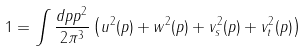<formula> <loc_0><loc_0><loc_500><loc_500>1 = \int \frac { d p p ^ { 2 } } { 2 \pi ^ { 3 } } \left ( u ^ { 2 } ( p ) + w ^ { 2 } ( p ) + v _ { s } ^ { 2 } ( p ) + v _ { t } ^ { 2 } ( p ) \right )</formula> 